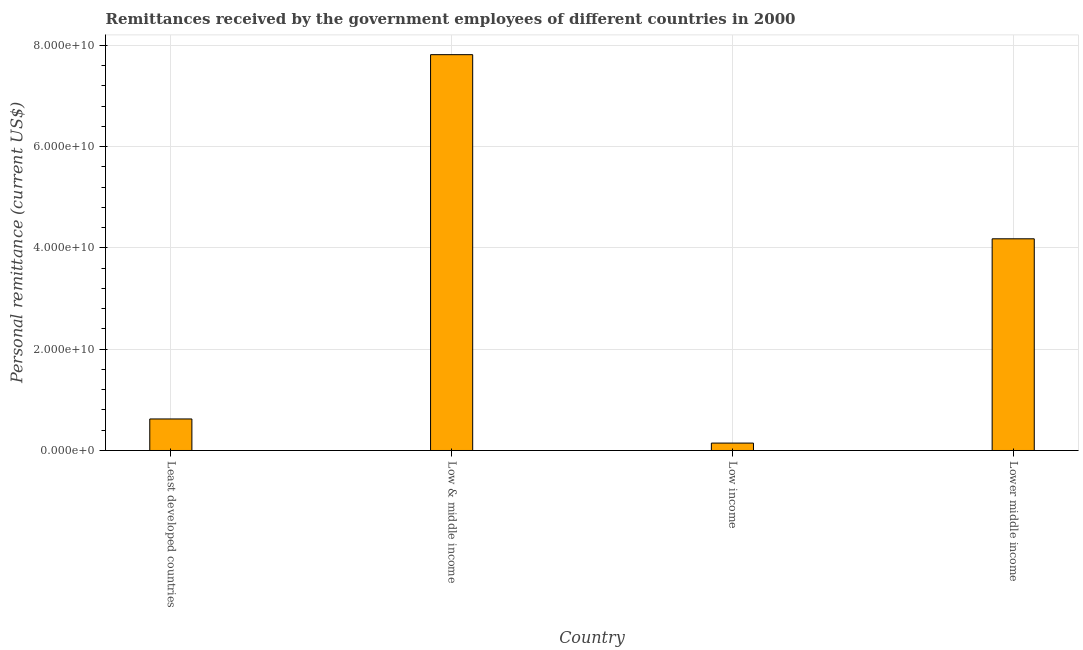Does the graph contain grids?
Ensure brevity in your answer.  Yes. What is the title of the graph?
Offer a terse response. Remittances received by the government employees of different countries in 2000. What is the label or title of the Y-axis?
Your answer should be compact. Personal remittance (current US$). What is the personal remittances in Lower middle income?
Your response must be concise. 4.18e+1. Across all countries, what is the maximum personal remittances?
Offer a terse response. 7.82e+1. Across all countries, what is the minimum personal remittances?
Ensure brevity in your answer.  1.46e+09. In which country was the personal remittances maximum?
Give a very brief answer. Low & middle income. In which country was the personal remittances minimum?
Your answer should be very brief. Low income. What is the sum of the personal remittances?
Provide a succinct answer. 1.28e+11. What is the difference between the personal remittances in Least developed countries and Low & middle income?
Your answer should be very brief. -7.19e+1. What is the average personal remittances per country?
Make the answer very short. 3.19e+1. What is the median personal remittances?
Make the answer very short. 2.40e+1. In how many countries, is the personal remittances greater than 76000000000 US$?
Keep it short and to the point. 1. What is the ratio of the personal remittances in Low & middle income to that in Low income?
Offer a terse response. 53.52. What is the difference between the highest and the second highest personal remittances?
Your response must be concise. 3.64e+1. What is the difference between the highest and the lowest personal remittances?
Keep it short and to the point. 7.67e+1. In how many countries, is the personal remittances greater than the average personal remittances taken over all countries?
Make the answer very short. 2. Are all the bars in the graph horizontal?
Your answer should be very brief. No. Are the values on the major ticks of Y-axis written in scientific E-notation?
Offer a very short reply. Yes. What is the Personal remittance (current US$) in Least developed countries?
Your answer should be compact. 6.22e+09. What is the Personal remittance (current US$) of Low & middle income?
Provide a short and direct response. 7.82e+1. What is the Personal remittance (current US$) of Low income?
Offer a terse response. 1.46e+09. What is the Personal remittance (current US$) of Lower middle income?
Keep it short and to the point. 4.18e+1. What is the difference between the Personal remittance (current US$) in Least developed countries and Low & middle income?
Keep it short and to the point. -7.19e+1. What is the difference between the Personal remittance (current US$) in Least developed countries and Low income?
Offer a terse response. 4.76e+09. What is the difference between the Personal remittance (current US$) in Least developed countries and Lower middle income?
Your answer should be very brief. -3.56e+1. What is the difference between the Personal remittance (current US$) in Low & middle income and Low income?
Make the answer very short. 7.67e+1. What is the difference between the Personal remittance (current US$) in Low & middle income and Lower middle income?
Your answer should be compact. 3.64e+1. What is the difference between the Personal remittance (current US$) in Low income and Lower middle income?
Ensure brevity in your answer.  -4.03e+1. What is the ratio of the Personal remittance (current US$) in Least developed countries to that in Low & middle income?
Your answer should be compact. 0.08. What is the ratio of the Personal remittance (current US$) in Least developed countries to that in Low income?
Offer a terse response. 4.26. What is the ratio of the Personal remittance (current US$) in Least developed countries to that in Lower middle income?
Ensure brevity in your answer.  0.15. What is the ratio of the Personal remittance (current US$) in Low & middle income to that in Low income?
Your answer should be very brief. 53.52. What is the ratio of the Personal remittance (current US$) in Low & middle income to that in Lower middle income?
Make the answer very short. 1.87. What is the ratio of the Personal remittance (current US$) in Low income to that in Lower middle income?
Provide a succinct answer. 0.04. 